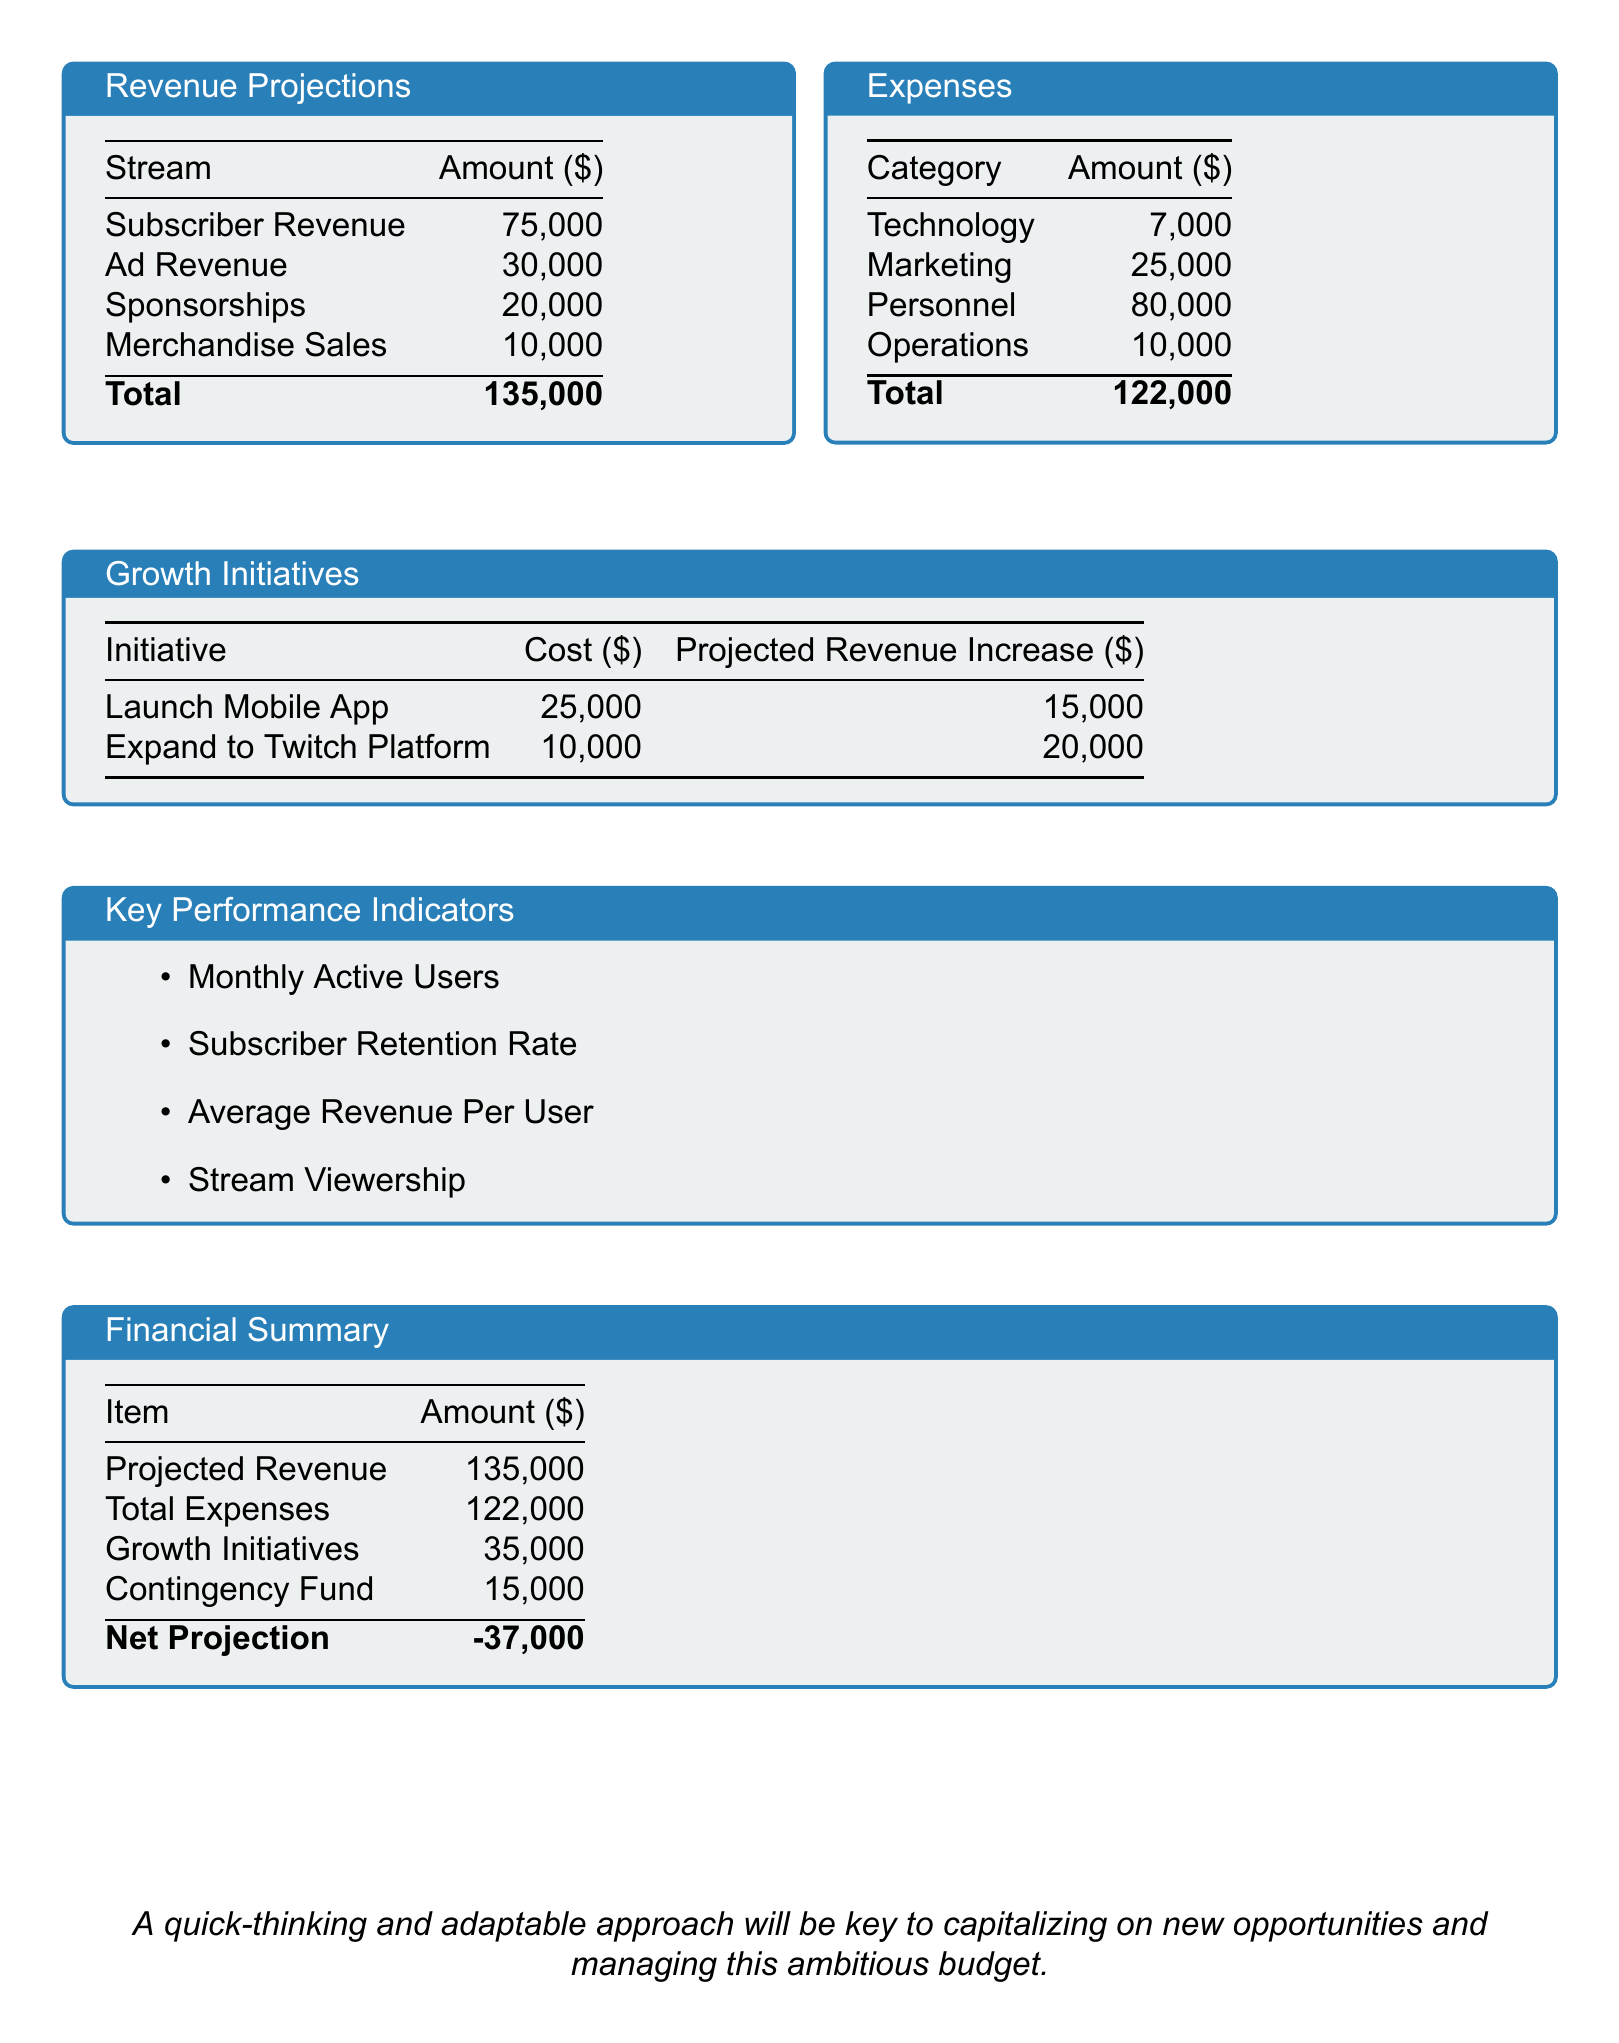What is the total projected revenue? The total projected revenue is the sum of all revenue sources listed, which is $75,000 + $30,000 + $20,000 + $10,000 = $135,000.
Answer: $135,000 What are the total expenses? The total expenses amount is calculated from all the categories listed, which is $7,000 + $25,000 + $80,000 + $10,000 = $122,000.
Answer: $122,000 What is the cost to launch the mobile app? The cost to launch the mobile app is provided in the growth initiatives section of the document.
Answer: $25,000 What is the projected revenue increase from expanding to the Twitch platform? The projected revenue increase from this initiative is listed in the growth initiatives section.
Answer: $20,000 What is the net projection? The net projection is obtained by subtracting the total expenses and growth initiatives cost from the projected revenue, which leads to $135,000 - $122,000 - $35,000 = -$37,000.
Answer: -$37,000 Which key performance indicator measures subscriber retention? The list of key performance indicators includes different metrics, one of which focuses on retention.
Answer: Subscriber Retention Rate What category has the highest expense? The highest expense is the category listed as personnel expenses in the expenses section.
Answer: Personnel How much is allocated for the contingency fund? The allocation for the contingency fund is specified in the financial summary section of the document.
Answer: $15,000 